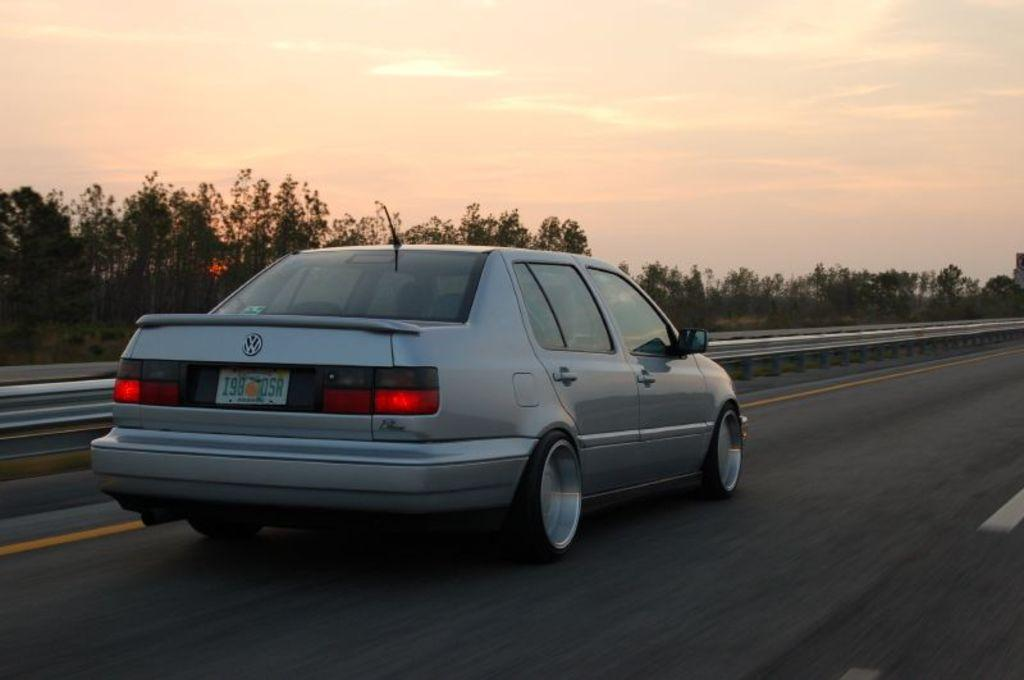What is the main subject of the image? The main subject of the image is a car. What is the car doing in the image? The car is moving on the road. What can be seen in the background of the image? There are trees and a fence in the background of the image. How would you describe the weather based on the image? The sky is cloudy in the image. What type of history can be seen in the image? There is no history present in the image; it features a car moving on the road with a cloudy sky and trees and a fence in the background. What kind of calculator is being used by the ducks in the image? There are no ducks or calculators present in the image. 